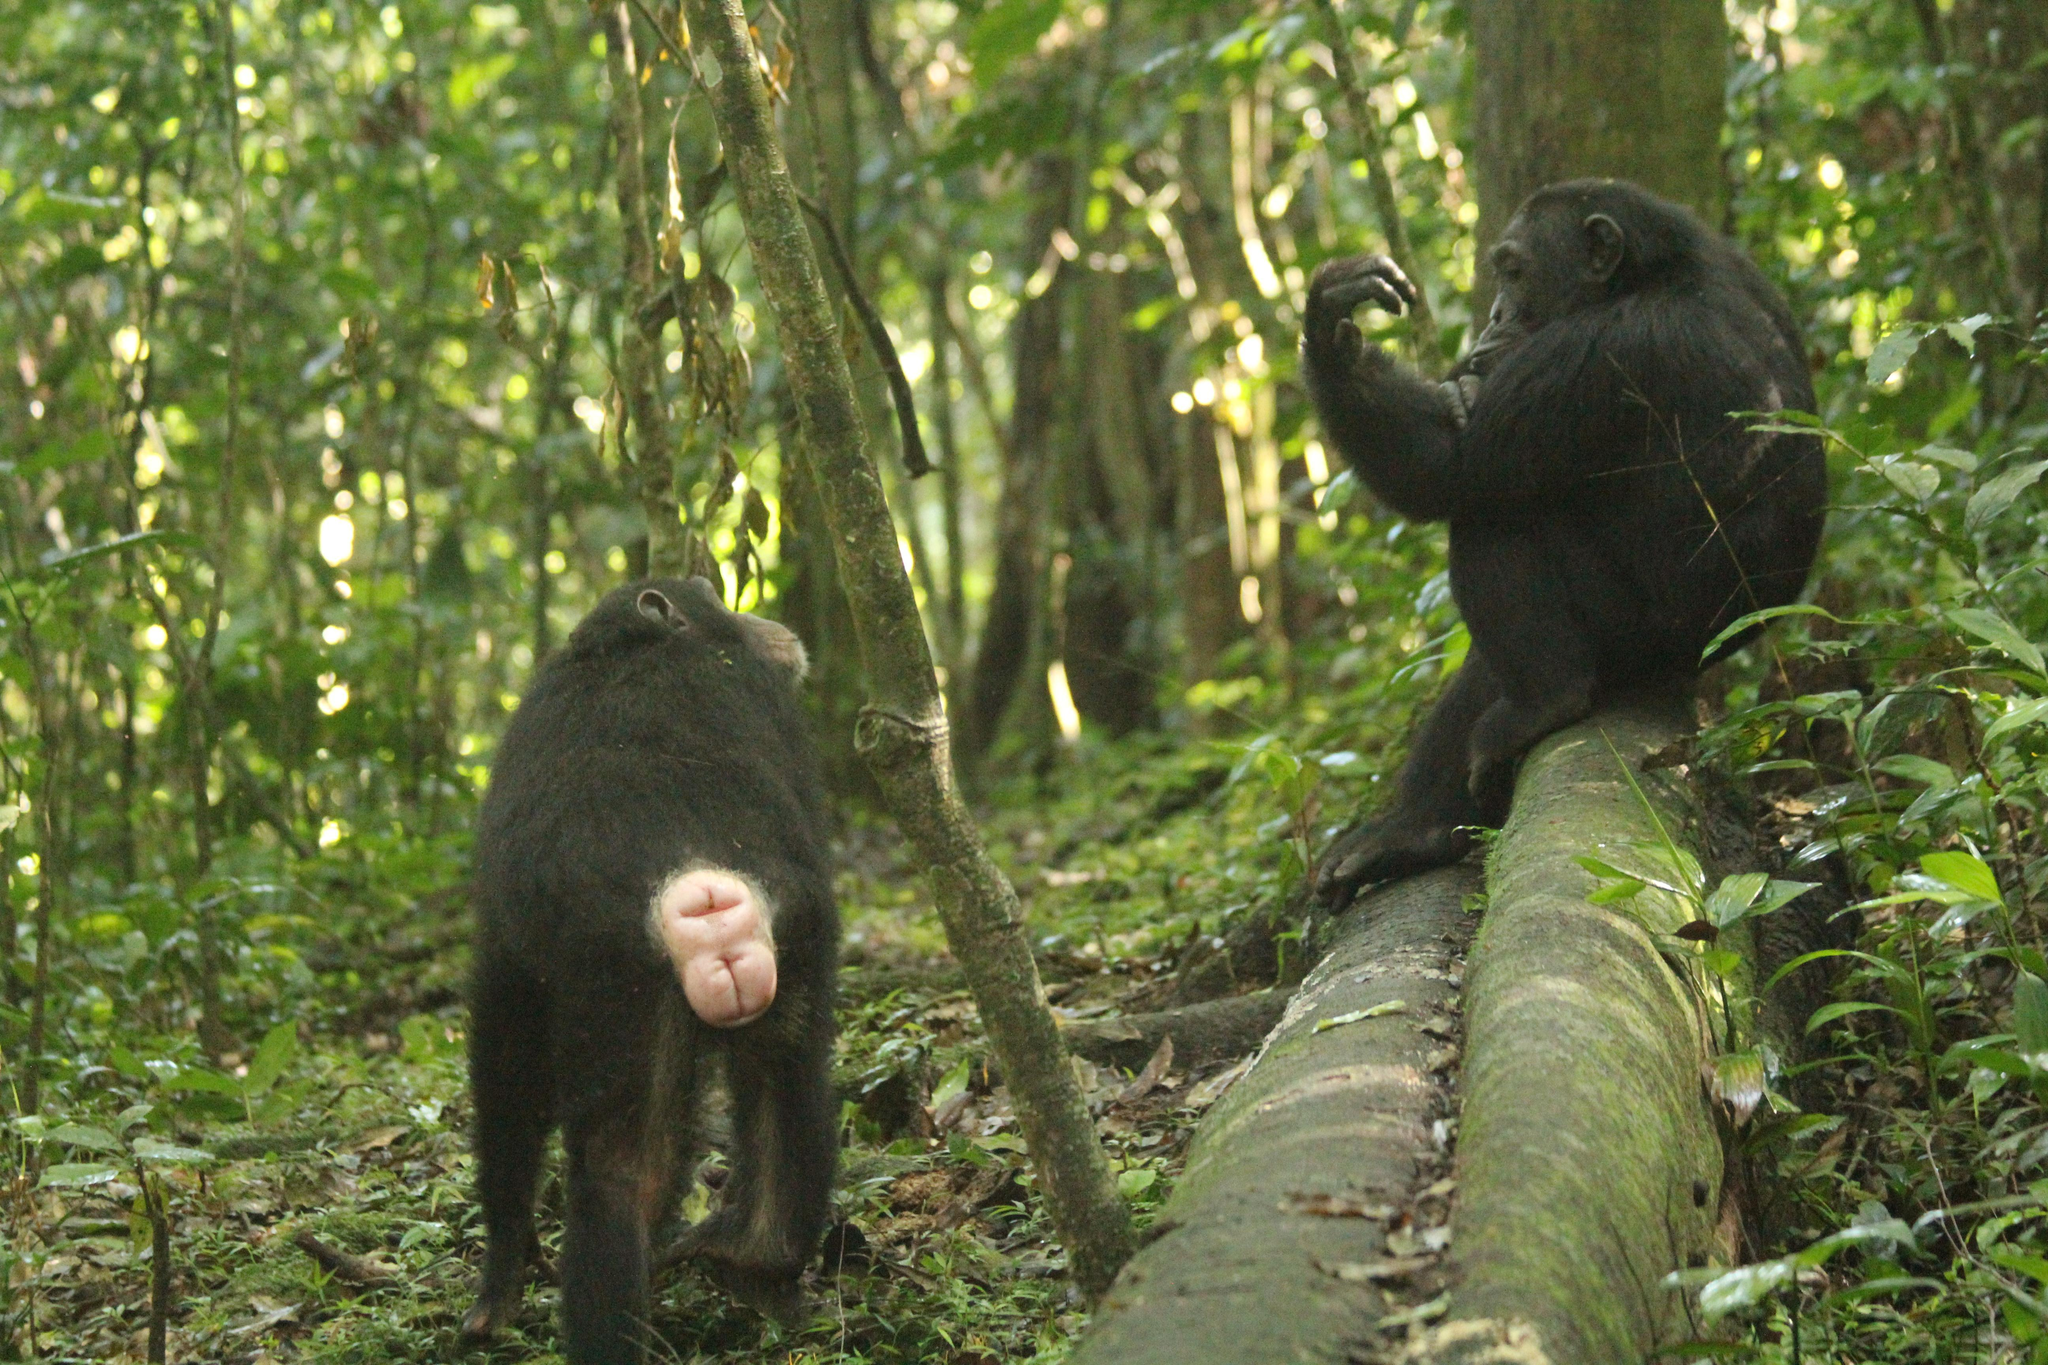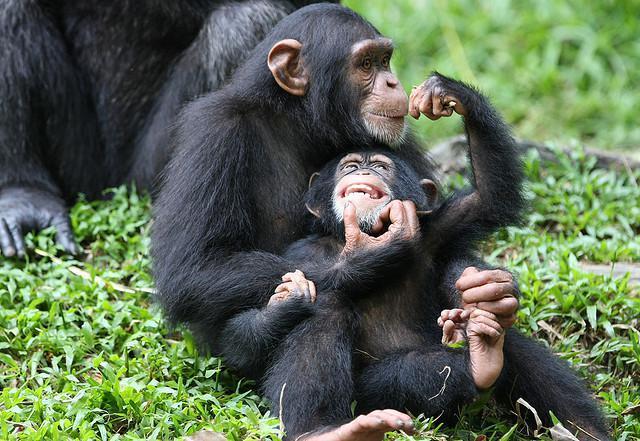The first image is the image on the left, the second image is the image on the right. Given the left and right images, does the statement "One image has a single monkey who has his mouth open, with a visible tree in the background and green grass." hold true? Answer yes or no. No. The first image is the image on the left, the second image is the image on the right. Considering the images on both sides, is "An image with more than one ape shows the bulbous pinkish rear of one ape." valid? Answer yes or no. Yes. 